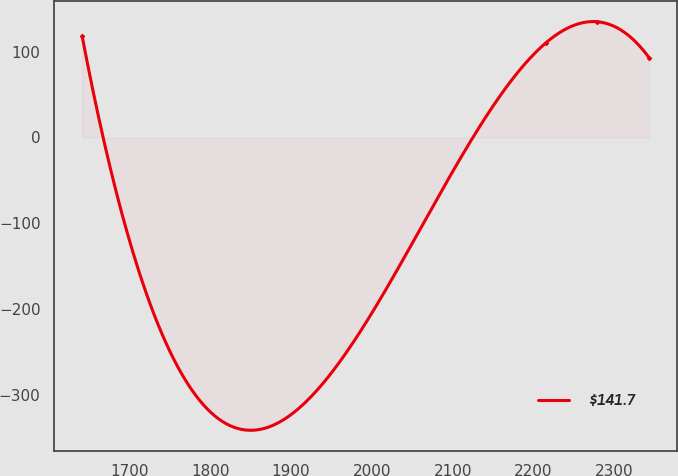Convert chart. <chart><loc_0><loc_0><loc_500><loc_500><line_chart><ecel><fcel>$141.7<nl><fcel>1641.57<fcel>118.14<nl><fcel>2215.31<fcel>110.3<nl><fcel>2279.09<fcel>134.92<nl><fcel>2342.88<fcel>93.21<nl></chart> 